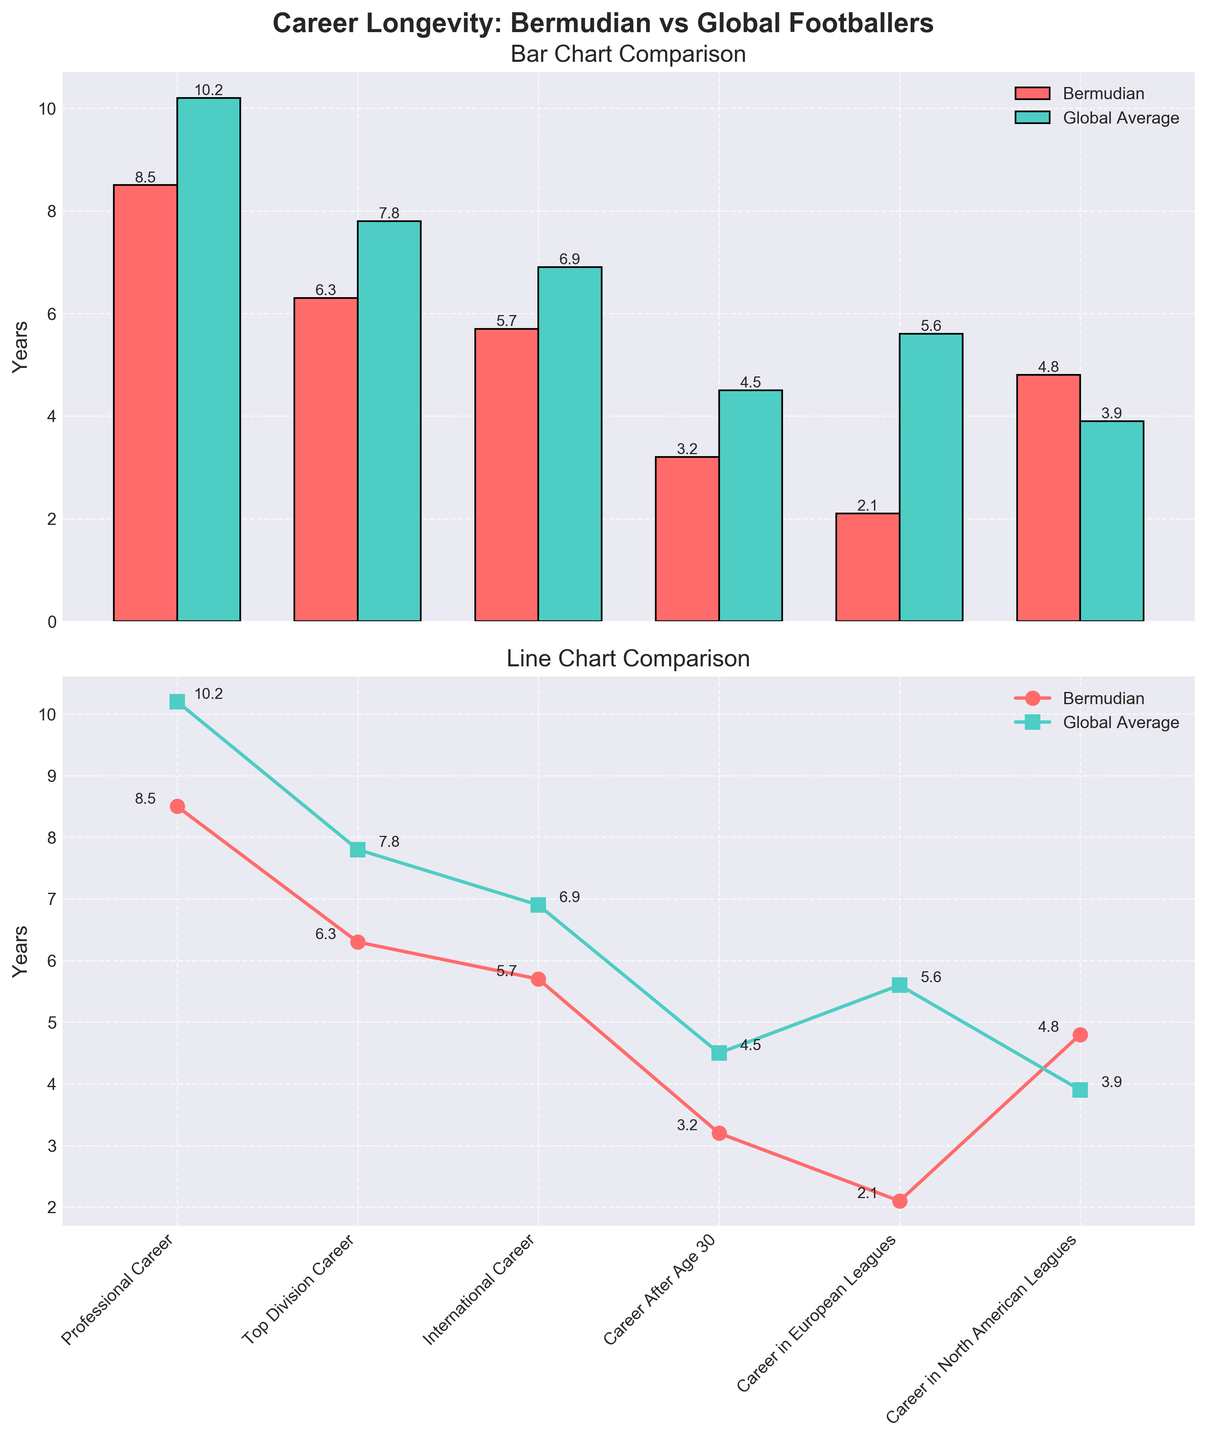What is the title of the figure? The title is displayed at the top center of the figure. It reads "Career Longevity: Bermudian vs Global Footballers".
Answer: Career Longevity: Bermudian vs Global Footballers What are the categories listed on the x-axis? The categories can be identified by looking at the labels on the x-axis of the subplots. They are: Professional Career, Top Division Career, International Career, Career After Age 30, Career in European Leagues, and Career in North American Leagues.
Answer: Professional Career, Top Division Career, International Career, Career After Age 30, Career in European Leagues, Career in North American Leagues Which category shows the largest difference in career longevity between Bermudian footballers and the global average? By observing the lengths of the bars in the Bar Chart Comparison subplot, the largest difference is seen in the "Career in European Leagues" category. Bermudian footballers have a career longevity of 2.1 years compared to the global average of 5.6 years.
Answer: Career in European Leagues In which category do Bermudian footballers have a longer career than the global average? From the bar and line charts, it is visible that Bermudian footballers surpass the global average in the "Career in North American Leagues" category: 4.8 years for Bermudian footballers versus 3.9 years globally.
Answer: Career in North American Leagues What is the difference in career longevity between Bermudian footballers and the global average for the "International Career" category? In the "International Career" category, Bermudian footballers have a career longevity of 5.7 years and the global average is 6.9 years. The difference is calculated as 6.9 - 5.7, which equals 1.2 years.
Answer: 1.2 years Which category shows the least difference in career longevity between Bermudian footballers and the global average? By comparing the bars and lines, the "Career After Age 30" category displays the smallest difference. Bermudian footballers have a longevity of 3.2 years, while the global average is 4.5 years, a difference of just 1.3 years.
Answer: Career After Age 30 What is the average career longevity of Bermudian footballers across all categories? To find the average, sum up the Bermudian footballers' longevity in all categories: 8.5 + 6.3 + 5.7 + 3.2 + 2.1 + 4.8 = 30.6, then divide by the number of categories (6): 30.6 / 6 = 5.1 years.
Answer: 5.1 years On which subplot do you see the data represented by lines and markers? The subplot showing data with lines and markers is the second one, titled "Line Chart Comparison". It features lines with circular and square markers for Bermudian and global averages, respectively.
Answer: Line Chart Comparison 